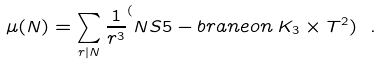<formula> <loc_0><loc_0><loc_500><loc_500>\mu ( N ) = \sum _ { r | N } \frac { 1 } { r ^ { 3 } } ^ { ( } N S 5 - b r a n e o n \, K _ { 3 } \times T ^ { 2 } ) \ .</formula> 